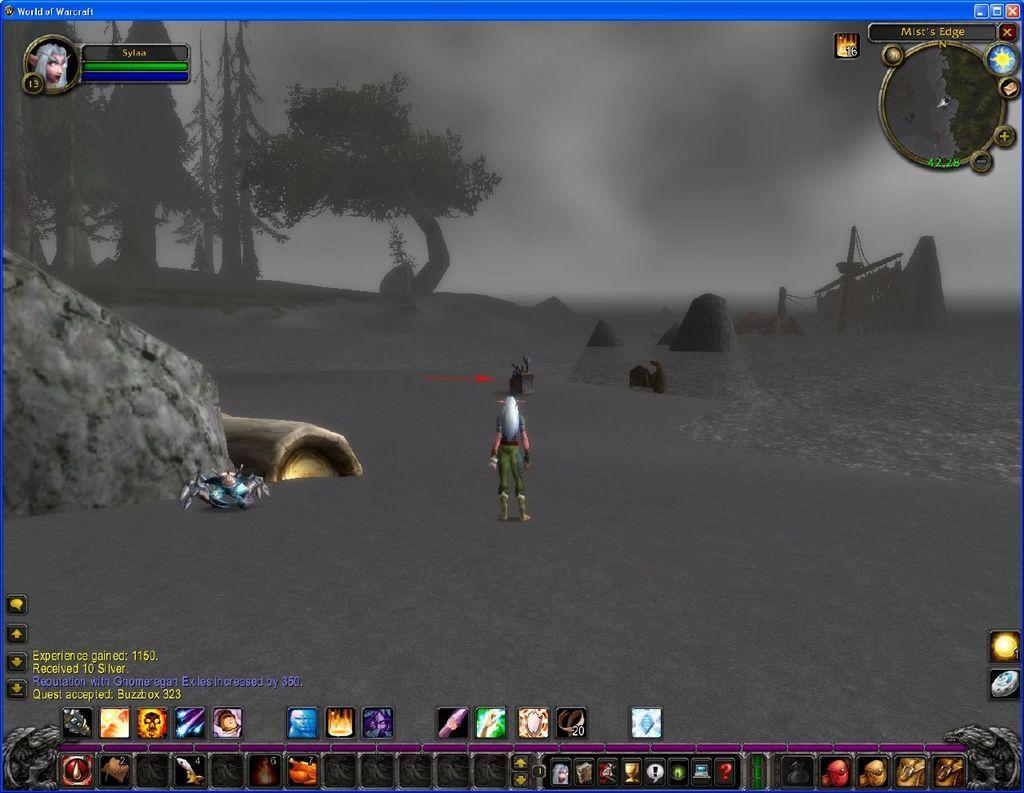Could you give a brief overview of what you see in this image? In this picture we can observe graphics. There is a person standing on the land. On the right side we can observe a map. There are some blocks. In the background there are trees and a sky. We can observe water on the right side. 